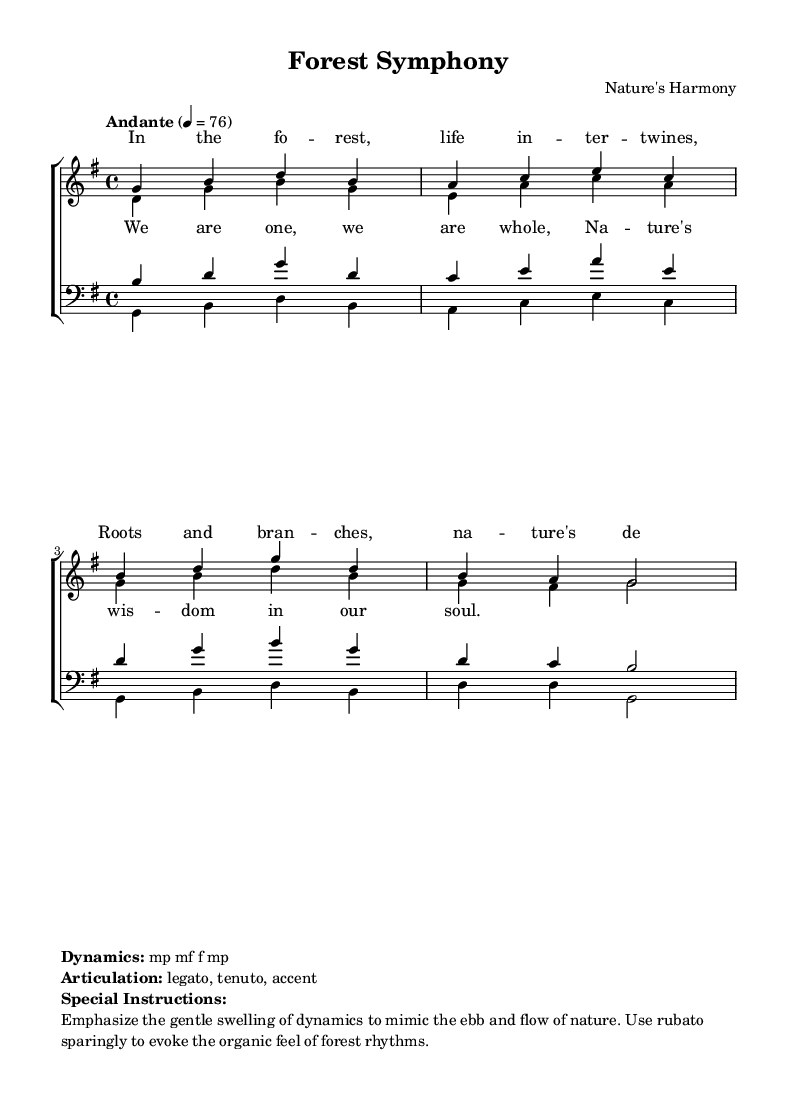What is the key signature of this music? The key signature is G major, which contains one sharp (F#). This can be inferred from the key signature shown at the beginning of the score.
Answer: G major What is the time signature of this piece? The time signature is 4/4, which indicates four beats per measure with a quarter note getting one beat. This is shown at the start of the score.
Answer: 4/4 What is the tempo marking for this choral work? The tempo marking is "Andante," which indicates a moderate pace. This is noted in the tempo section of the score.
Answer: Andante How many vocal parts are written in the music? There are four vocal parts: soprano, alto, tenor, and bass. This can be counted from the different voice entries in the score, each marked distinctly.
Answer: Four What dynamic markings are indicated in the score? The dynamic markings include mp, mf, f, and back to mp. These are specified in the markup section, noting how the volume should swell and recede.
Answer: mp, mf, f What type of music is represented in this piece? This piece is a lyrical choral work, characterized by its focus on interconnectedness of ecosystems, and its romantic musical qualities. It incorporates themes of unity and nature in both the lyrics and composition.
Answer: Lyrical choral work What special instructions are given for the performance of this music? The special instructions emphasize gentle dynamics that mimic nature's rhythms and suggest using rubato sparingly. This provides insight into the interpretive nature of the piece.
Answer: Emphasize the gentle swelling of dynamics 